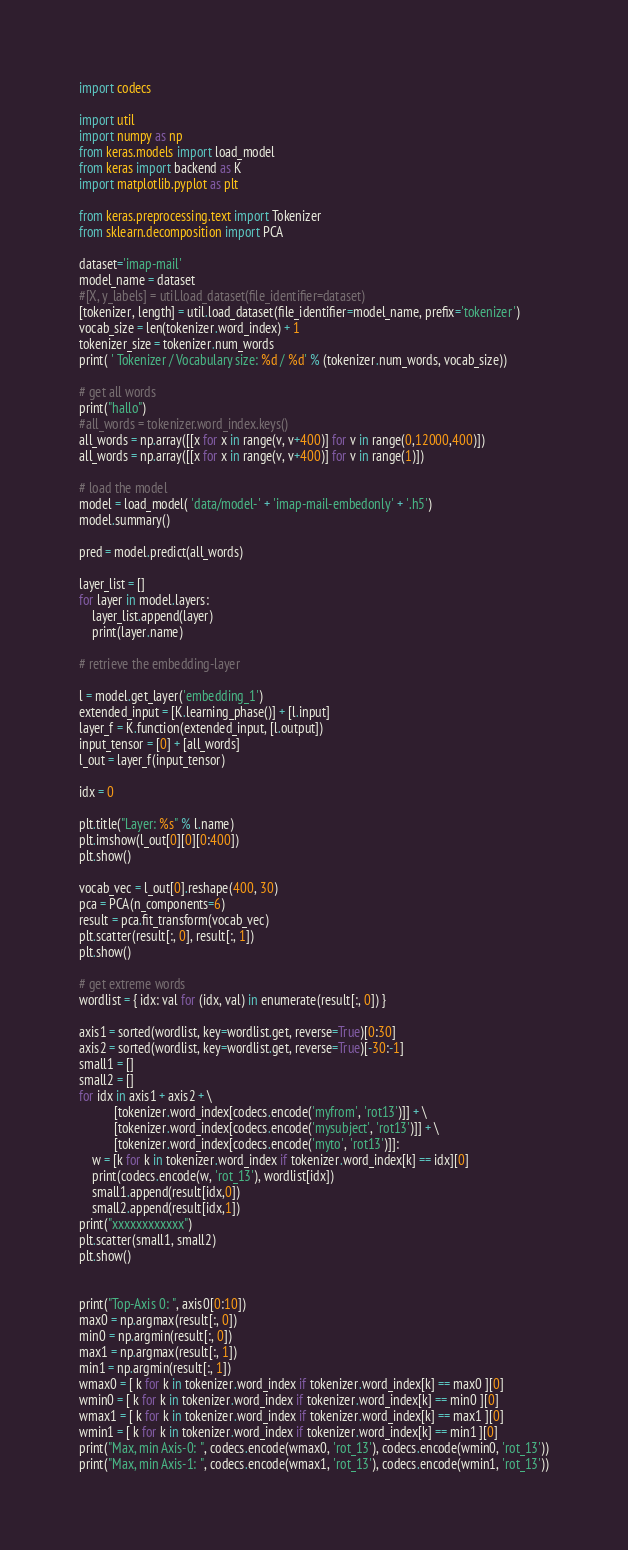<code> <loc_0><loc_0><loc_500><loc_500><_Python_>import codecs

import util
import numpy as np
from keras.models import load_model
from keras import backend as K
import matplotlib.pyplot as plt

from keras.preprocessing.text import Tokenizer
from sklearn.decomposition import PCA

dataset='imap-mail'
model_name = dataset
#[X, y_labels] = util.load_dataset(file_identifier=dataset)
[tokenizer, length] = util.load_dataset(file_identifier=model_name, prefix='tokenizer')
vocab_size = len(tokenizer.word_index) + 1
tokenizer_size = tokenizer.num_words
print( ' Tokenizer / Vocabulary size: %d / %d' % (tokenizer.num_words, vocab_size))

# get all words
print("hallo")
#all_words = tokenizer.word_index.keys()
all_words = np.array([[x for x in range(v, v+400)] for v in range(0,12000,400)])
all_words = np.array([[x for x in range(v, v+400)] for v in range(1)])

# load the model
model = load_model( 'data/model-' + 'imap-mail-embedonly' + '.h5')
model.summary()

pred = model.predict(all_words)

layer_list = []
for layer in model.layers:
    layer_list.append(layer)
    print(layer.name)

# retrieve the embedding-layer

l = model.get_layer('embedding_1')
extended_input = [K.learning_phase()] + [l.input]
layer_f = K.function(extended_input, [l.output])
input_tensor = [0] + [all_words]
l_out = layer_f(input_tensor)

idx = 0

plt.title("Layer: %s" % l.name)
plt.imshow(l_out[0][0][0:400])
plt.show()

vocab_vec = l_out[0].reshape(400, 30)
pca = PCA(n_components=6)
result = pca.fit_transform(vocab_vec)
plt.scatter(result[:, 0], result[:, 1])
plt.show()

# get extreme words
wordlist = { idx: val for (idx, val) in enumerate(result[:, 0]) }

axis1 = sorted(wordlist, key=wordlist.get, reverse=True)[0:30]
axis2 = sorted(wordlist, key=wordlist.get, reverse=True)[-30:-1]
small1 = []
small2 = []
for idx in axis1 + axis2 + \
           [tokenizer.word_index[codecs.encode('myfrom', 'rot13')]] + \
           [tokenizer.word_index[codecs.encode('mysubject', 'rot13')]] + \
           [tokenizer.word_index[codecs.encode('myto', 'rot13')]]:
    w = [k for k in tokenizer.word_index if tokenizer.word_index[k] == idx][0]
    print(codecs.encode(w, 'rot_13'), wordlist[idx])
    small1.append(result[idx,0])
    small2.append(result[idx,1])
print("xxxxxxxxxxxx")
plt.scatter(small1, small2)
plt.show()


print("Top-Axis 0: ", axis0[0:10])
max0 = np.argmax(result[:, 0])
min0 = np.argmin(result[:, 0])
max1 = np.argmax(result[:, 1])
min1 = np.argmin(result[:, 1])
wmax0 = [ k for k in tokenizer.word_index if tokenizer.word_index[k] == max0 ][0]
wmin0 = [ k for k in tokenizer.word_index if tokenizer.word_index[k] == min0 ][0]
wmax1 = [ k for k in tokenizer.word_index if tokenizer.word_index[k] == max1 ][0]
wmin1 = [ k for k in tokenizer.word_index if tokenizer.word_index[k] == min1 ][0]
print("Max, min Axis-0: ", codecs.encode(wmax0, 'rot_13'), codecs.encode(wmin0, 'rot_13'))
print("Max, min Axis-1: ", codecs.encode(wmax1, 'rot_13'), codecs.encode(wmin1, 'rot_13'))



</code> 